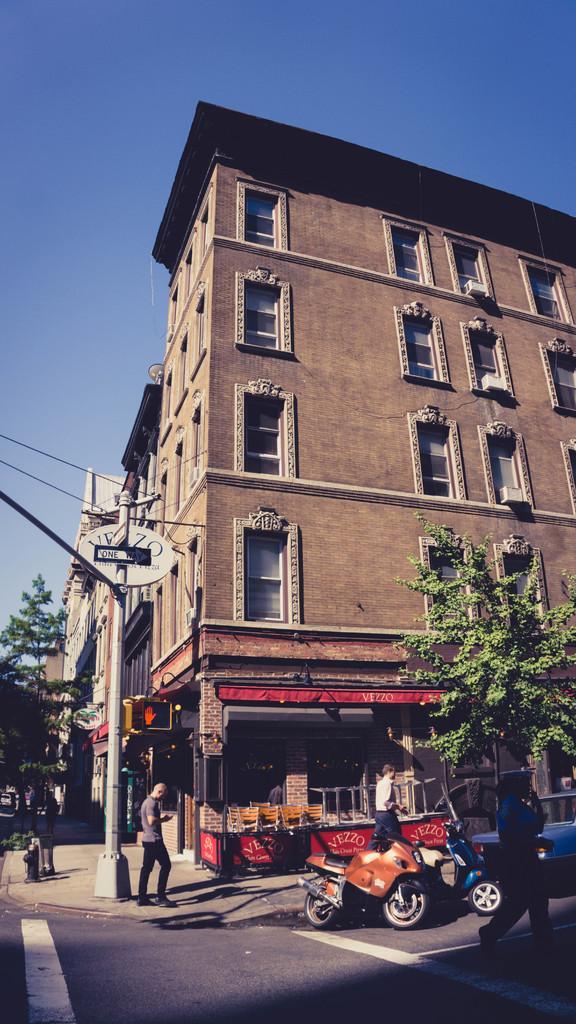Can you describe this image briefly? There are vehicles parked and a person walking on the road on which, there are white color lines. In the background, there are persons, a pole, tree on the footpath, there are buildings and there is blue sky. 